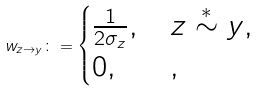<formula> <loc_0><loc_0><loc_500><loc_500>w _ { z \to y } \colon = \begin{cases} \frac { 1 } { 2 \sigma _ { z } } , \, & z \stackrel { \ast } { \sim } y , \\ 0 , & , \end{cases}</formula> 